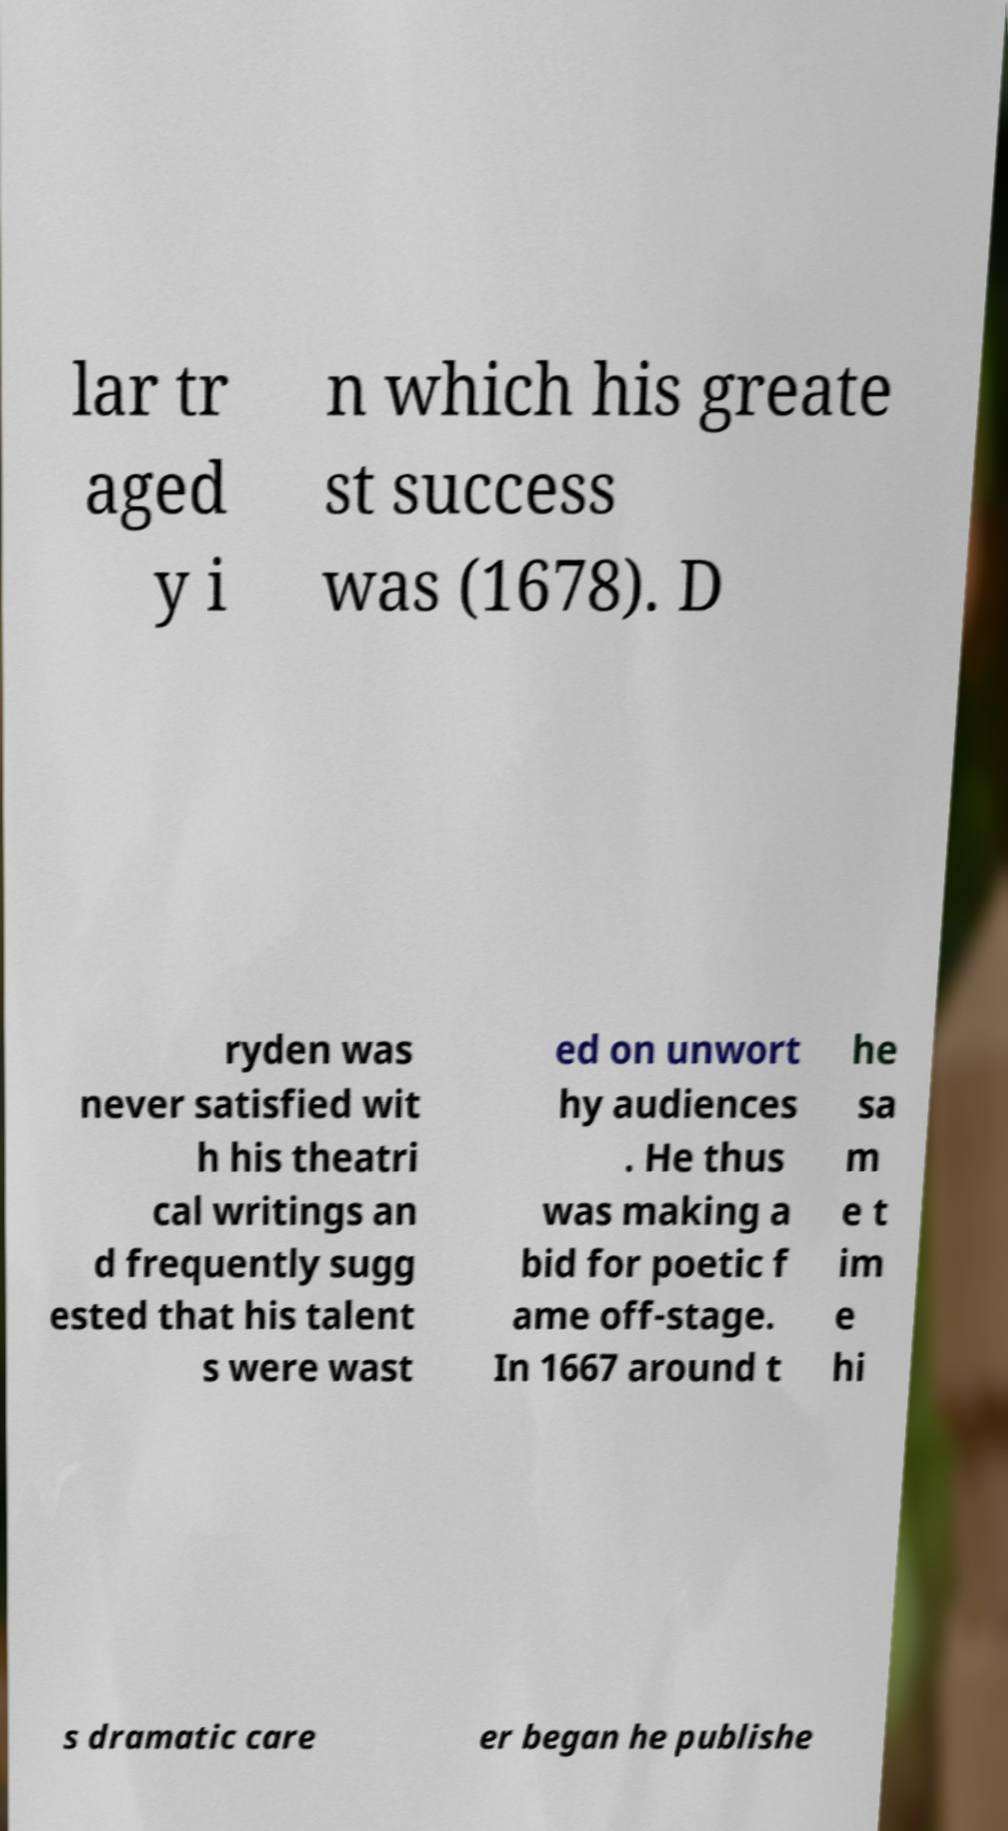For documentation purposes, I need the text within this image transcribed. Could you provide that? lar tr aged y i n which his greate st success was (1678). D ryden was never satisfied wit h his theatri cal writings an d frequently sugg ested that his talent s were wast ed on unwort hy audiences . He thus was making a bid for poetic f ame off-stage. In 1667 around t he sa m e t im e hi s dramatic care er began he publishe 